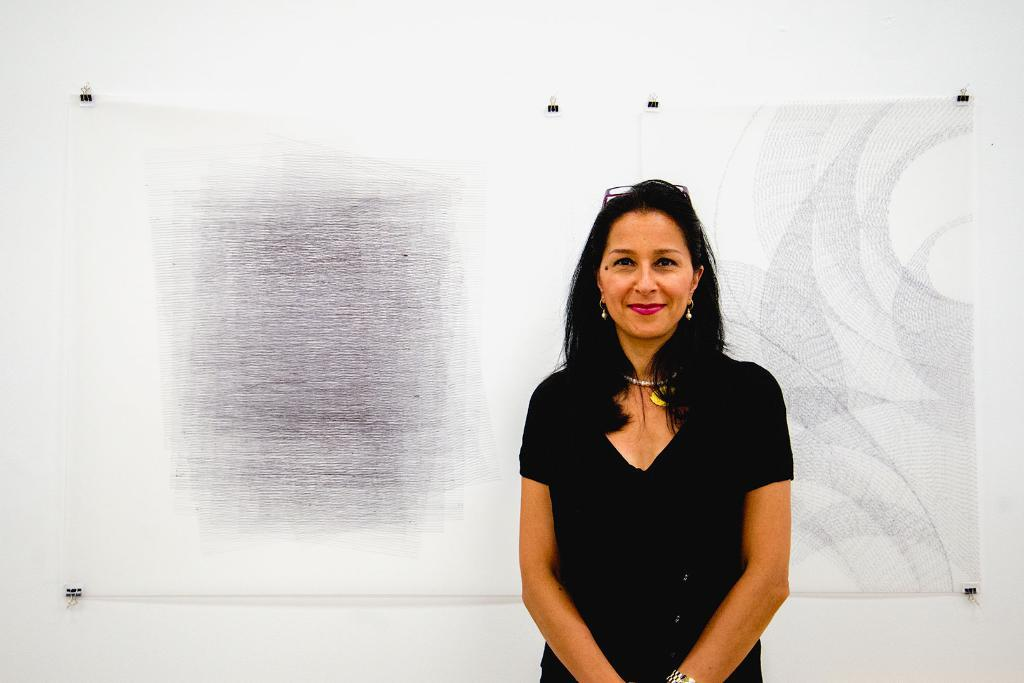Who is present in the image? There is a woman in the image. What is the woman wearing? The woman is wearing a black dress. What is the woman's facial expression? The woman is smiling. What is the woman's position in the image? The woman is standing and on the right side of the image. What can be seen in the background of the image? There is a painting in the background of the image. What is the color of the wall on which the painting is attached? The painting is attached to a white wall. What type of toothpaste is advertised in the image? There is no toothpaste or advertisement present in the image. How many things are visible in the image? The question is unclear as it does not specify what "things" are being referred to. However, based on the provided facts, we can definitively say that there is a woman, a black dress, a smile, a standing position, a right side, a painting, and a white wall present in the image. 